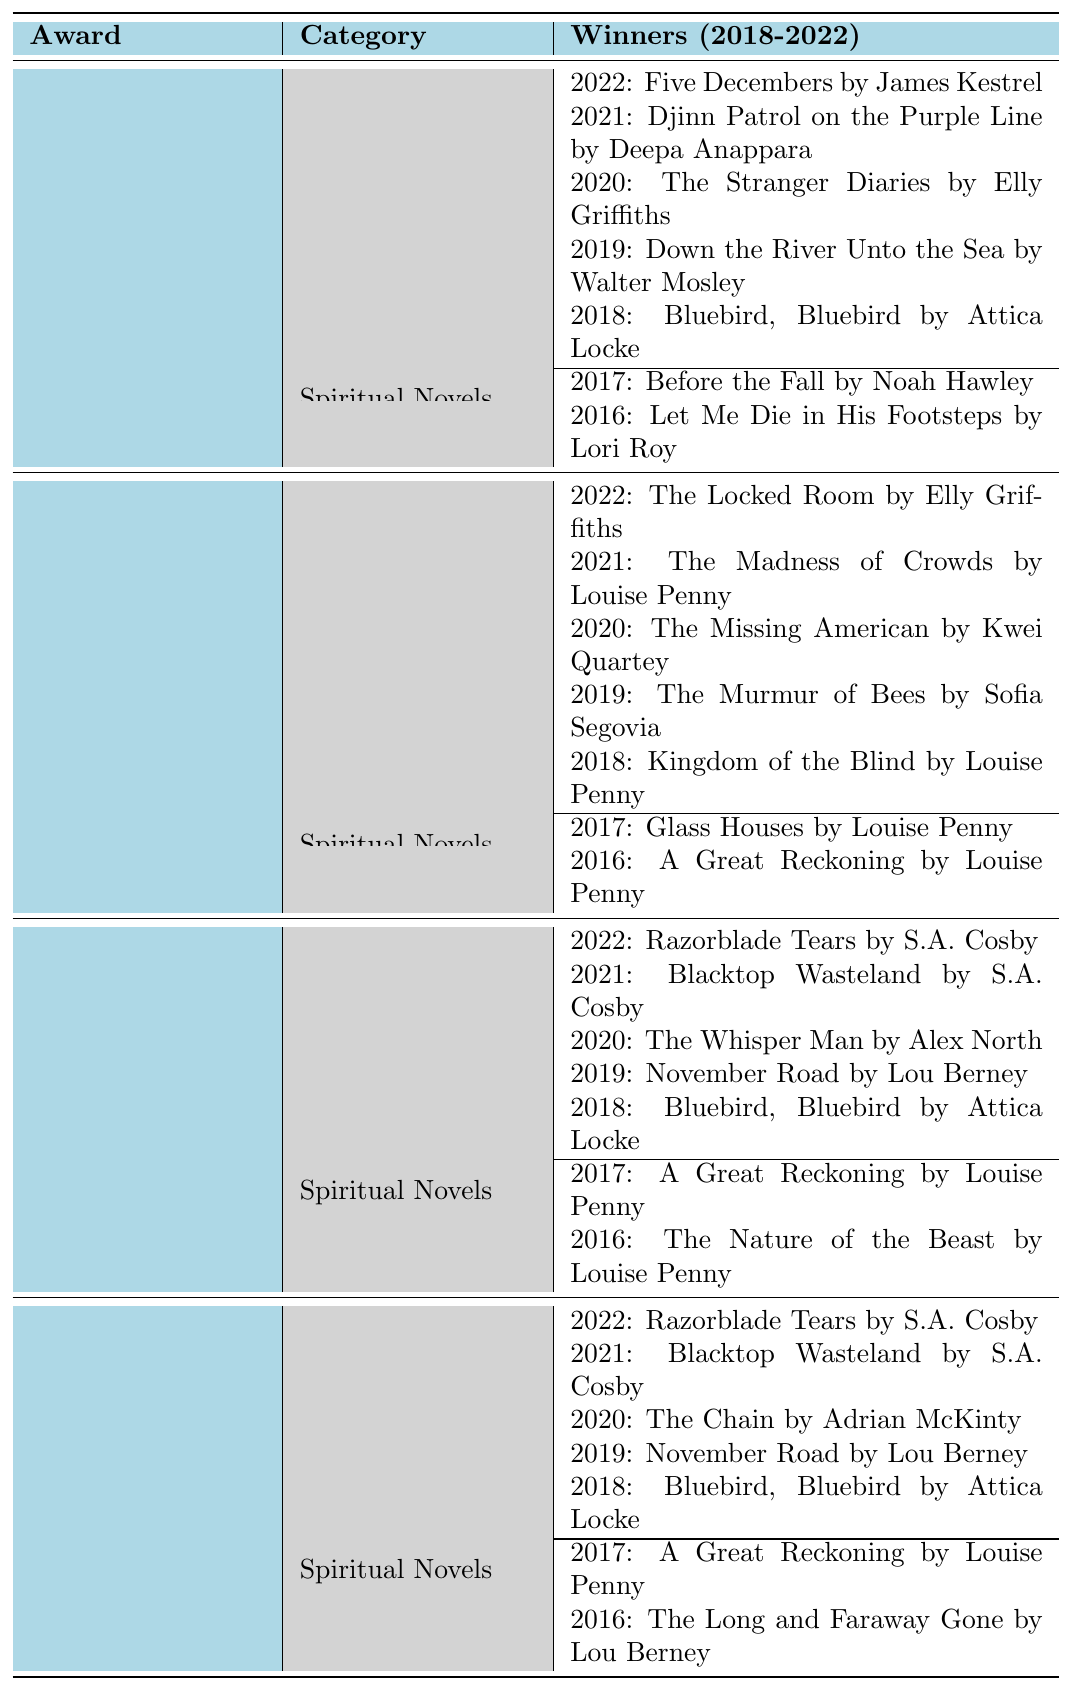What is the title of the secular novel that won the Edgar Allan Poe Award in 2022? Referring to the table under the Edgar Allan Poe Awards, the winner for Secular Novels in 2022 is listed as "Five Decembers by James Kestrel."
Answer: Five Decembers by James Kestrel How many spiritual novels won the Agatha Awards during the given period? The table shows two spiritual novels that won the Agatha Awards: "Glass Houses" in 2017 and "A Great Reckoning" in 2016. Therefore, the total is 2.
Answer: 2 Which award has the most winners for secular novels between 2018 and 2022? By counting the entries in the table under the Secular Novels category for each award, the Edgar Allan Poe Awards, Agatha Awards, Anthony Awards, and Macavity Awards all have 5 winners each from 2018 to 2022.
Answer: 5 winners Did "A Great Reckoning" win more than one literary award? "A Great Reckoning" is listed as a spiritual novel winner for both the Anthony and Agatha Awards in different years, thus confirming it won more than one award.
Answer: Yes Which spiritual novel was recognized in the Anthony Awards in 2017 and 2016? The spiritual novels listed under the Anthony Awards are "A Great Reckoning" in 2017 and "The Nature of the Beast" in 2016.
Answer: A Great Reckoning and The Nature of the Beast Compare the number of secular winners in the Edgar Allan Poe Awards to those in the Macavity Awards from 2018 to 2022. Both the Edgar Allan Poe Awards and the Macavity Awards have 5 secular winners listed from 2018 to 2022, indicating no difference in the number of secular winners between them.
Answer: They both have 5 secular winners What is the total number of spiritual novel winners across all awards for the years shown? Counting the spiritual winners, there are 2 from the Edgar Allan Poe Awards, 2 from the Agatha Awards, and 3 from the Anthony and Macavity Awards (both share the same 2 from the past years), giving us a total of 6 spiritual winners across all awards.
Answer: 6 Is there a secular novel that won the Macavity Award twice in consecutive years? There is no secular novel listed in the Macavity Awards that has won in consecutive years; all listed winners are unique for each year.
Answer: No Which award had the earliest win for a spiritual novel according to the table? The earliest win for a spiritual novel in the table is for the Edgar Allan Poe Awards in 2016, with "Let Me Die in His Footsteps" by Lori Roy.
Answer: Edgar Allan Poe Awards in 2016 If the Agatha Awards allowed both secular and spiritual novels to compete, how would that affect the total number of awarded novels listed? Given the current competition structure, adding spiritual novels to the Agatha Awards would raise the total awarded novels, which currently includes 5 secular and 2 spiritual novels, thereby increasing the total to 7 if they were combined.
Answer: Total would be 7 